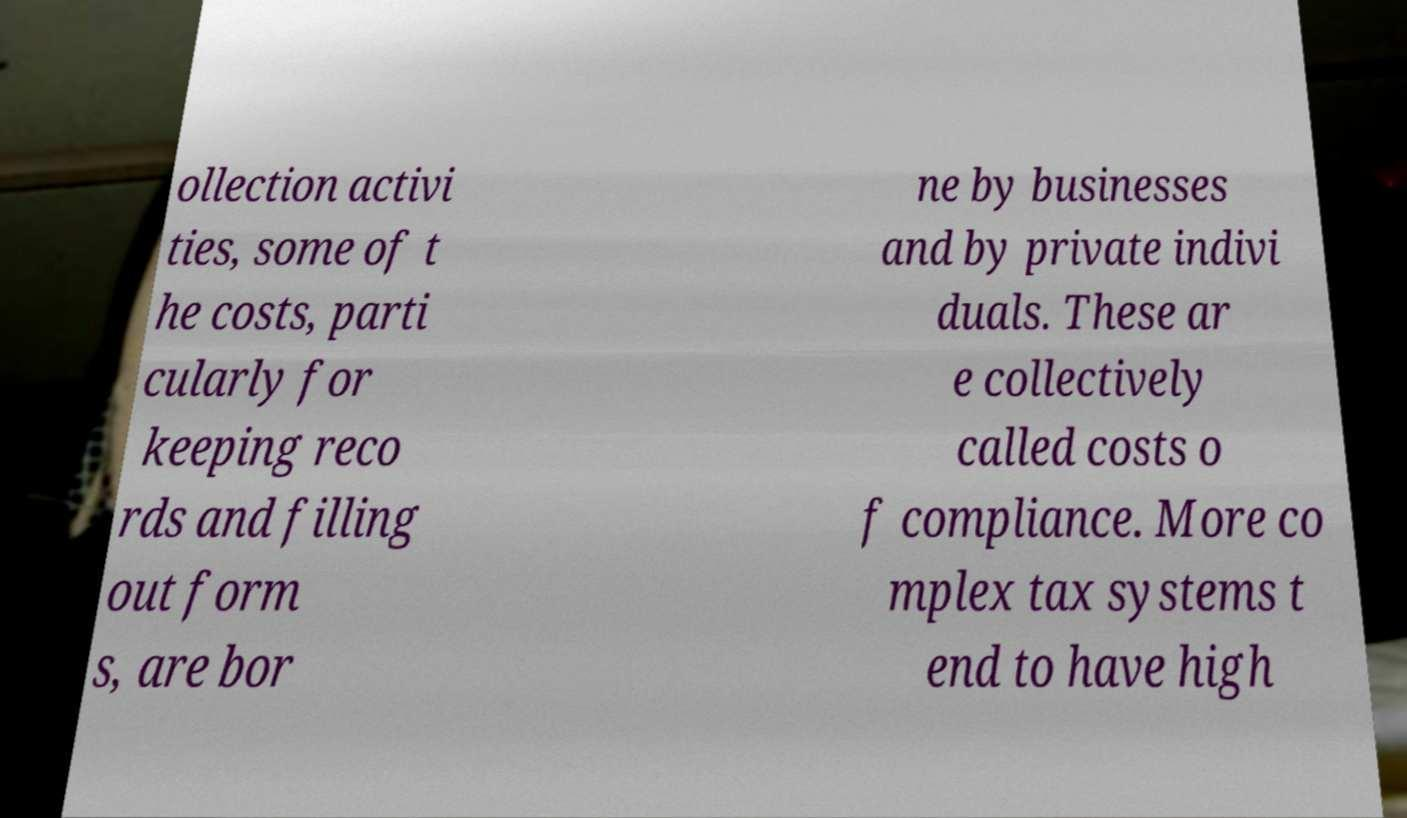Please identify and transcribe the text found in this image. ollection activi ties, some of t he costs, parti cularly for keeping reco rds and filling out form s, are bor ne by businesses and by private indivi duals. These ar e collectively called costs o f compliance. More co mplex tax systems t end to have high 